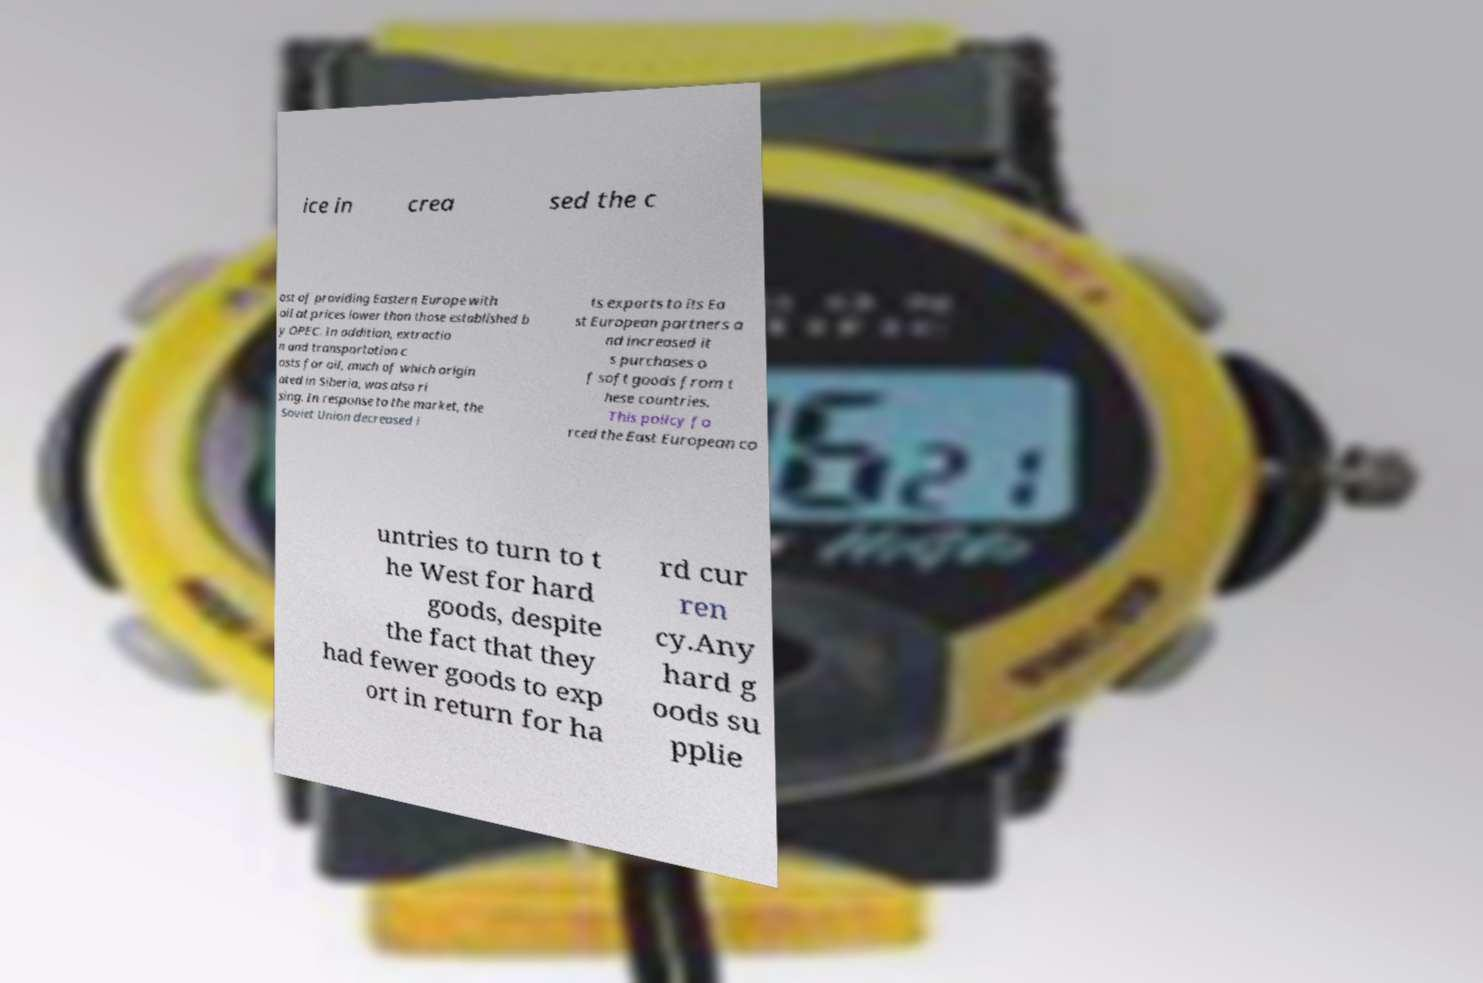For documentation purposes, I need the text within this image transcribed. Could you provide that? ice in crea sed the c ost of providing Eastern Europe with oil at prices lower than those established b y OPEC. In addition, extractio n and transportation c osts for oil, much of which origin ated in Siberia, was also ri sing. In response to the market, the Soviet Union decreased i ts exports to its Ea st European partners a nd increased it s purchases o f soft goods from t hese countries. This policy fo rced the East European co untries to turn to t he West for hard goods, despite the fact that they had fewer goods to exp ort in return for ha rd cur ren cy.Any hard g oods su pplie 